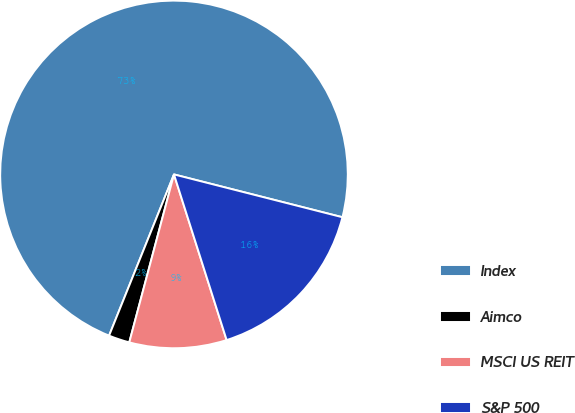Convert chart. <chart><loc_0><loc_0><loc_500><loc_500><pie_chart><fcel>Index<fcel>Aimco<fcel>MSCI US REIT<fcel>S&P 500<nl><fcel>72.87%<fcel>1.95%<fcel>9.04%<fcel>16.14%<nl></chart> 